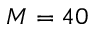<formula> <loc_0><loc_0><loc_500><loc_500>M = 4 0</formula> 